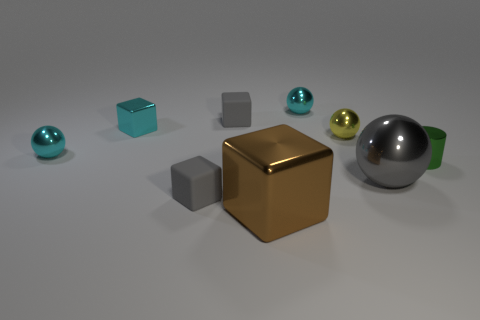Is the cyan cube the same size as the brown shiny cube?
Your response must be concise. No. Is there a small brown shiny block?
Provide a succinct answer. No. Is the shape of the gray shiny thing the same as the yellow shiny thing?
Give a very brief answer. Yes. How many cylinders are to the right of the matte object in front of the shiny object on the right side of the large gray sphere?
Offer a very short reply. 1. There is a object that is in front of the large gray thing and on the left side of the large brown metallic block; what is it made of?
Provide a short and direct response. Rubber. The thing that is behind the gray metallic ball and on the right side of the yellow sphere is what color?
Your answer should be compact. Green. Is there any other thing of the same color as the large shiny cube?
Your answer should be compact. No. The big metallic object on the left side of the cyan metal ball behind the tiny rubber object behind the small metallic cube is what shape?
Your answer should be very brief. Cube. The other big metallic thing that is the same shape as the yellow object is what color?
Provide a succinct answer. Gray. There is a rubber thing behind the green cylinder on the right side of the big shiny sphere; what color is it?
Keep it short and to the point. Gray. 